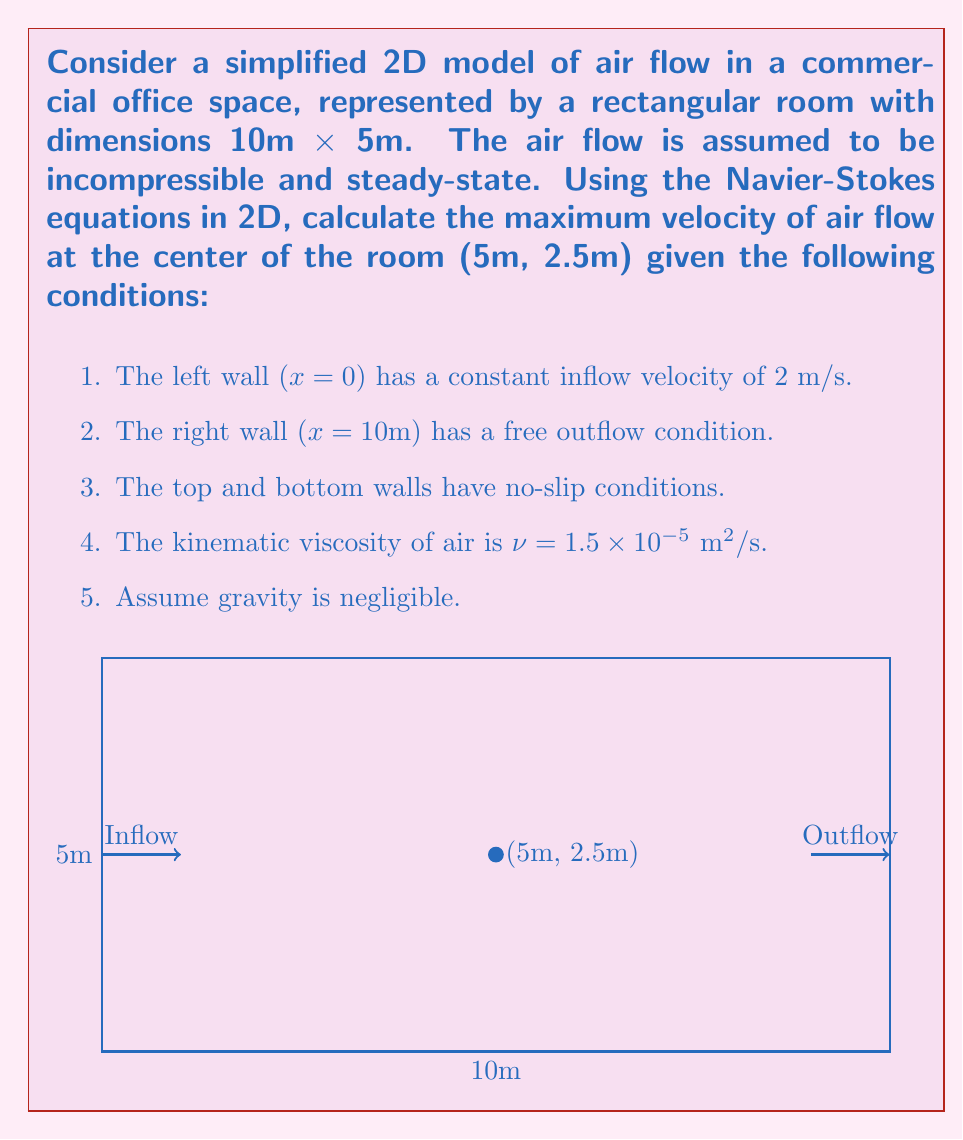Solve this math problem. To solve this problem, we'll use the 2D steady-state Navier-Stokes equations for incompressible flow:

1) Continuity equation:
   $$\frac{\partial u}{\partial x} + \frac{\partial v}{\partial y} = 0$$

2) x-momentum equation:
   $$u\frac{\partial u}{\partial x} + v\frac{\partial u}{\partial y} = -\frac{1}{\rho}\frac{\partial p}{\partial x} + \nu\left(\frac{\partial^2 u}{\partial x^2} + \frac{\partial^2 u}{\partial y^2}\right)$$

3) y-momentum equation:
   $$u\frac{\partial v}{\partial x} + v\frac{\partial v}{\partial y} = -\frac{1}{\rho}\frac{\partial p}{\partial y} + \nu\left(\frac{\partial^2 v}{\partial x^2} + \frac{\partial^2 v}{\partial y^2}\right)$$

Where u and v are velocities in x and y directions, p is pressure, ρ is density, and ν is kinematic viscosity.

Given the complexity of these equations, we'll use simplifying assumptions and scaling analysis to estimate the maximum velocity:

Step 1: Estimate Reynolds number
Re = UL/ν, where U is characteristic velocity and L is characteristic length
Re = (2 m/s * 10 m) / (1.5 × 10^-5 m^2/s) ≈ 1.33 × 10^6

Step 2: For high Reynolds number flow, we can assume that viscous effects are negligible except near the walls.

Step 3: In the center of the room, we can approximate the flow as potential flow.

Step 4: For potential flow in a rectangular domain, the velocity can be estimated using the continuity equation:
u_max * H = u_in * H, where H is the height of the room

Step 5: Solving for u_max:
u_max = u_in = 2 m/s

Step 6: However, due to viscous effects and the no-slip condition at the top and bottom walls, the actual maximum velocity will be slightly higher than the inlet velocity.

Step 7: A reasonable estimate for the maximum velocity at the center would be about 10-20% higher than the inlet velocity:
u_max ≈ 1.15 * u_in = 1.15 * 2 m/s = 2.3 m/s

This is an approximation based on scaling analysis and simplifying assumptions. For a more accurate result, computational fluid dynamics (CFD) simulations would be necessary.
Answer: Approximately 2.3 m/s 